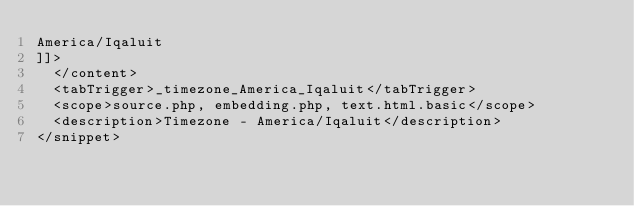Convert code to text. <code><loc_0><loc_0><loc_500><loc_500><_XML_>America/Iqaluit
]]>
	</content>
	<tabTrigger>_timezone_America_Iqaluit</tabTrigger>
	<scope>source.php, embedding.php, text.html.basic</scope>
	<description>Timezone - America/Iqaluit</description>
</snippet></code> 